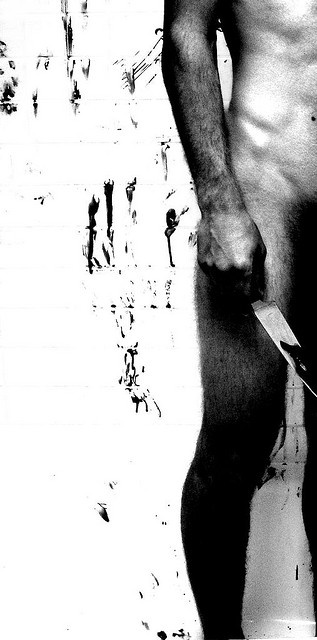Describe the objects in this image and their specific colors. I can see people in white, black, gray, darkgray, and lightgray tones and knife in white, black, lightgray, darkgray, and gray tones in this image. 